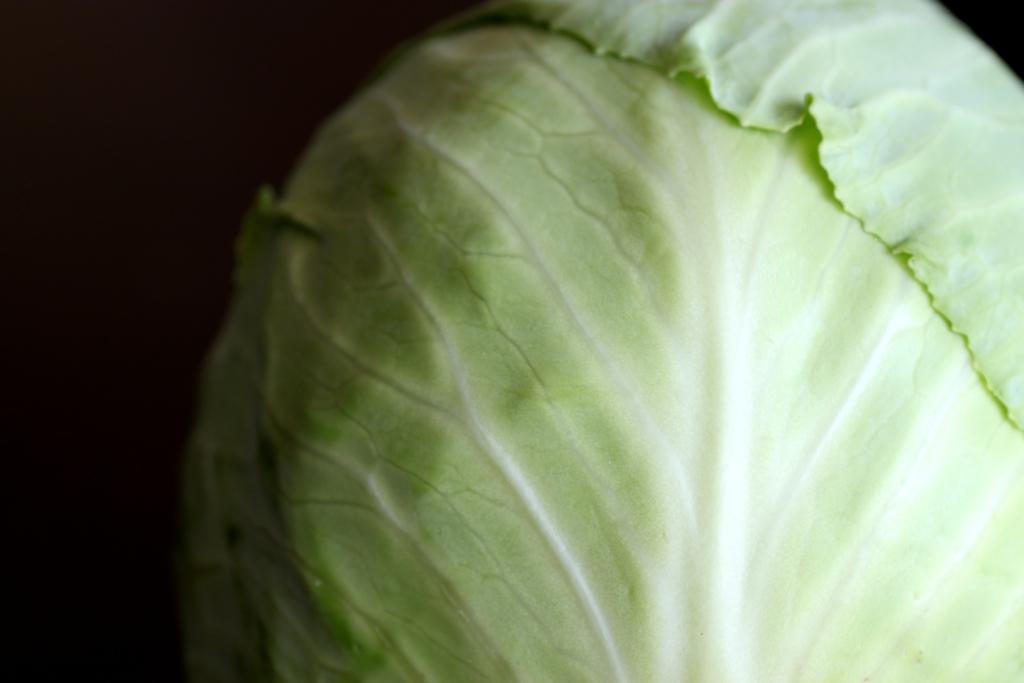Can you describe this image briefly? We can see cabbage. In the background it is dark. 